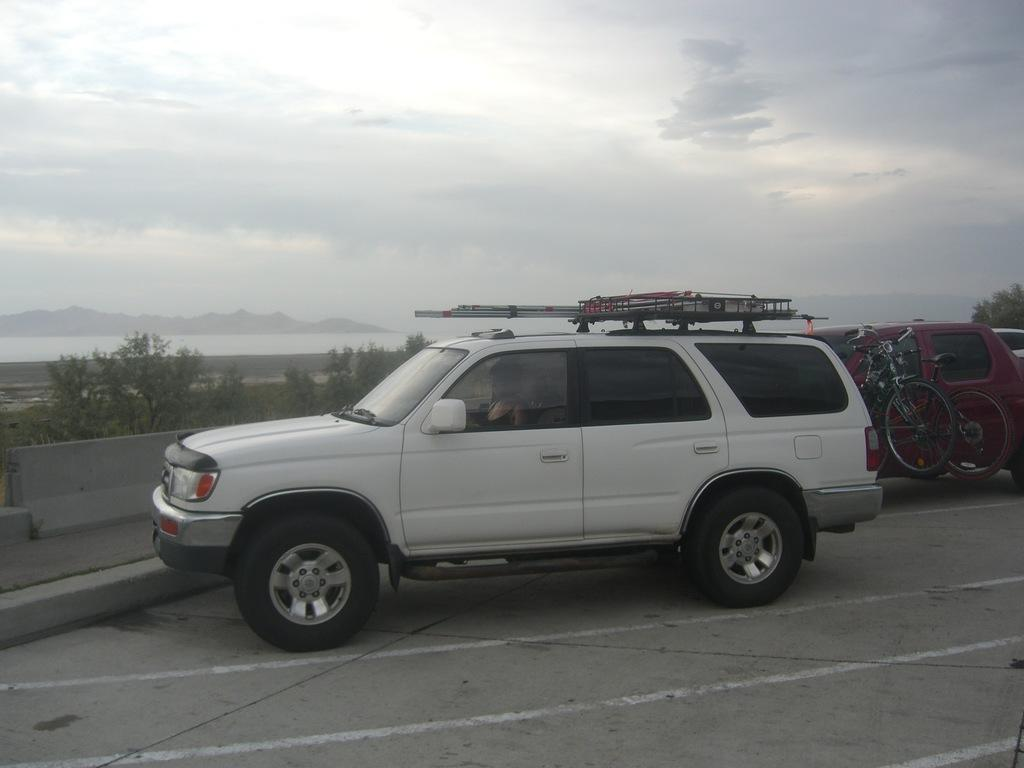What color is the vehicle on the road in the image? The vehicle on the road is white. What can be seen on the road besides the vehicle? There are white color lines on the road and other vehicles. What is visible in the background of the image? There are trees in the background of the image. What is visible in the sky in the image? There are clouds in the sky. Is there a gate visible in the yard in the image? There is no yard or gate present in the image; it features a road with vehicles and trees in the background. Is there a collar visible on any of the vehicles in the image? There are no collars present on the vehicles in the image; they are simply vehicles on the road. 